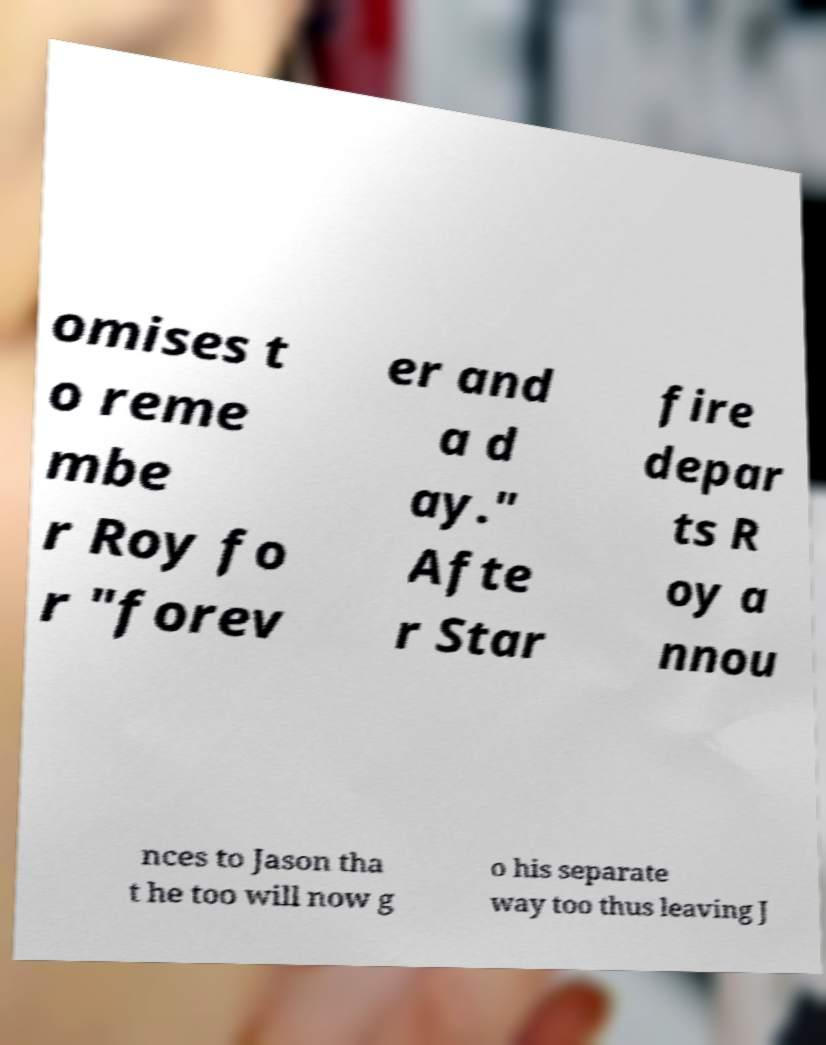Please identify and transcribe the text found in this image. omises t o reme mbe r Roy fo r "forev er and a d ay." Afte r Star fire depar ts R oy a nnou nces to Jason tha t he too will now g o his separate way too thus leaving J 